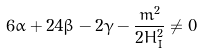<formula> <loc_0><loc_0><loc_500><loc_500>6 \alpha + 2 4 \beta - 2 \gamma - \frac { m ^ { 2 } } { 2 H _ { I } ^ { 2 } } \neq 0</formula> 